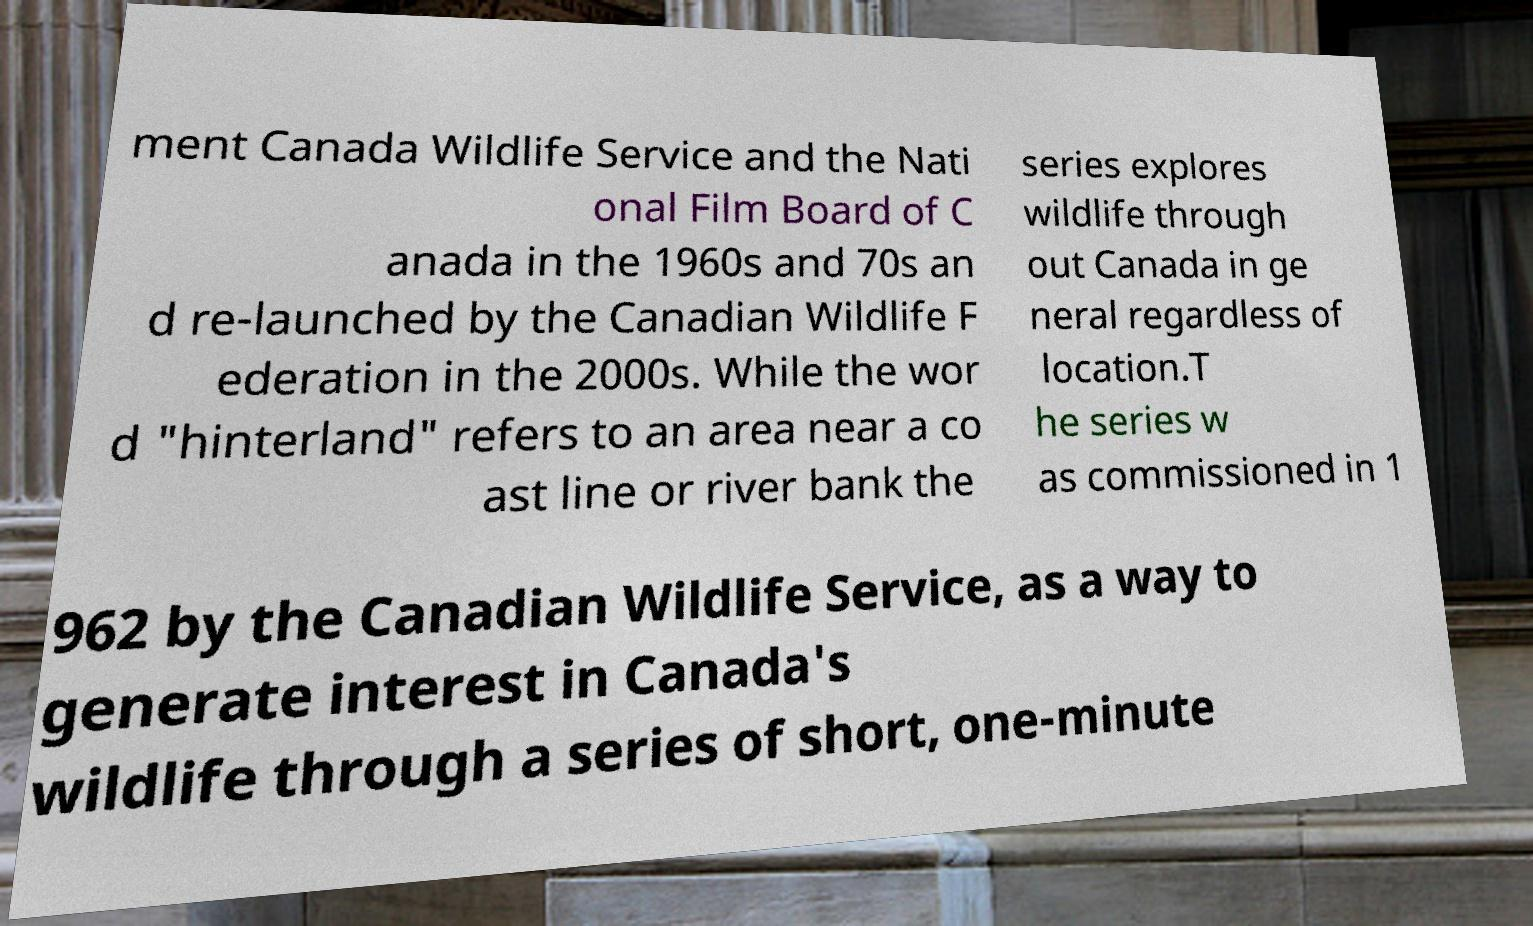Could you assist in decoding the text presented in this image and type it out clearly? ment Canada Wildlife Service and the Nati onal Film Board of C anada in the 1960s and 70s an d re-launched by the Canadian Wildlife F ederation in the 2000s. While the wor d "hinterland" refers to an area near a co ast line or river bank the series explores wildlife through out Canada in ge neral regardless of location.T he series w as commissioned in 1 962 by the Canadian Wildlife Service, as a way to generate interest in Canada's wildlife through a series of short, one-minute 